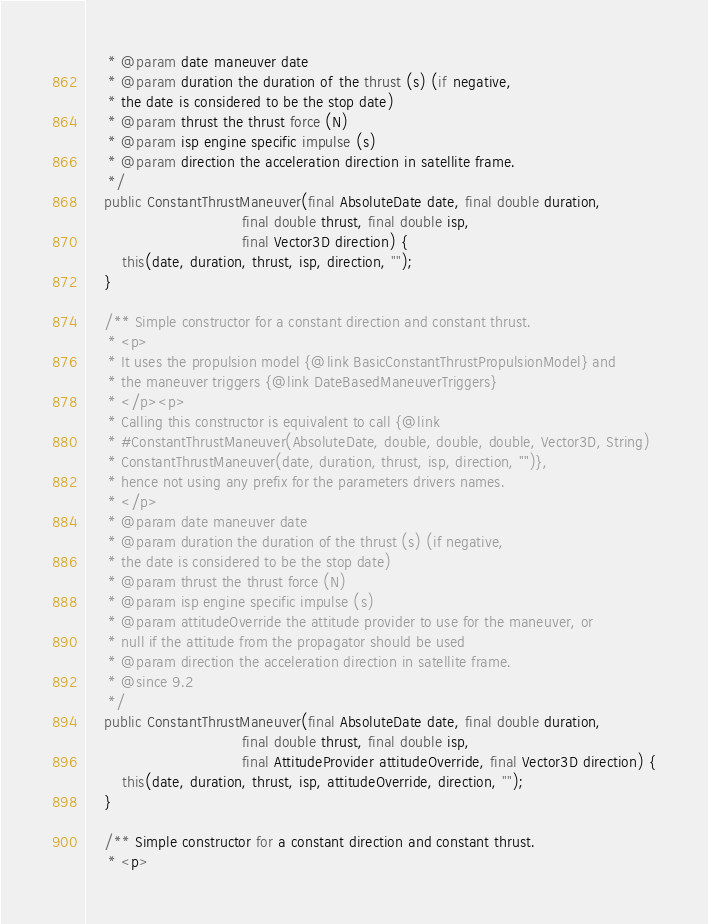<code> <loc_0><loc_0><loc_500><loc_500><_Java_>     * @param date maneuver date
     * @param duration the duration of the thrust (s) (if negative,
     * the date is considered to be the stop date)
     * @param thrust the thrust force (N)
     * @param isp engine specific impulse (s)
     * @param direction the acceleration direction in satellite frame.
     */
    public ConstantThrustManeuver(final AbsoluteDate date, final double duration,
                                  final double thrust, final double isp,
                                  final Vector3D direction) {
        this(date, duration, thrust, isp, direction, "");
    }

    /** Simple constructor for a constant direction and constant thrust.
     * <p>
     * It uses the propulsion model {@link BasicConstantThrustPropulsionModel} and
     * the maneuver triggers {@link DateBasedManeuverTriggers}
     * </p><p>
     * Calling this constructor is equivalent to call {@link
     * #ConstantThrustManeuver(AbsoluteDate, double, double, double, Vector3D, String)
     * ConstantThrustManeuver(date, duration, thrust, isp, direction, "")},
     * hence not using any prefix for the parameters drivers names.
     * </p>
     * @param date maneuver date
     * @param duration the duration of the thrust (s) (if negative,
     * the date is considered to be the stop date)
     * @param thrust the thrust force (N)
     * @param isp engine specific impulse (s)
     * @param attitudeOverride the attitude provider to use for the maneuver, or
     * null if the attitude from the propagator should be used
     * @param direction the acceleration direction in satellite frame.
     * @since 9.2
     */
    public ConstantThrustManeuver(final AbsoluteDate date, final double duration,
                                  final double thrust, final double isp,
                                  final AttitudeProvider attitudeOverride, final Vector3D direction) {
        this(date, duration, thrust, isp, attitudeOverride, direction, "");
    }

    /** Simple constructor for a constant direction and constant thrust.
     * <p></code> 